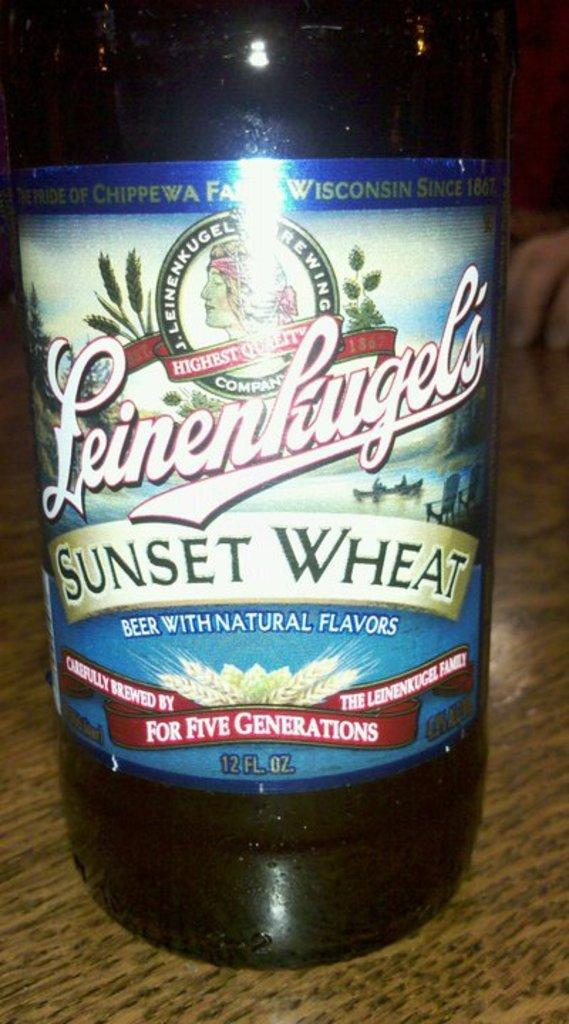<image>
Render a clear and concise summary of the photo. a sunset wheat bottle of liquid beer that is nicely designed 